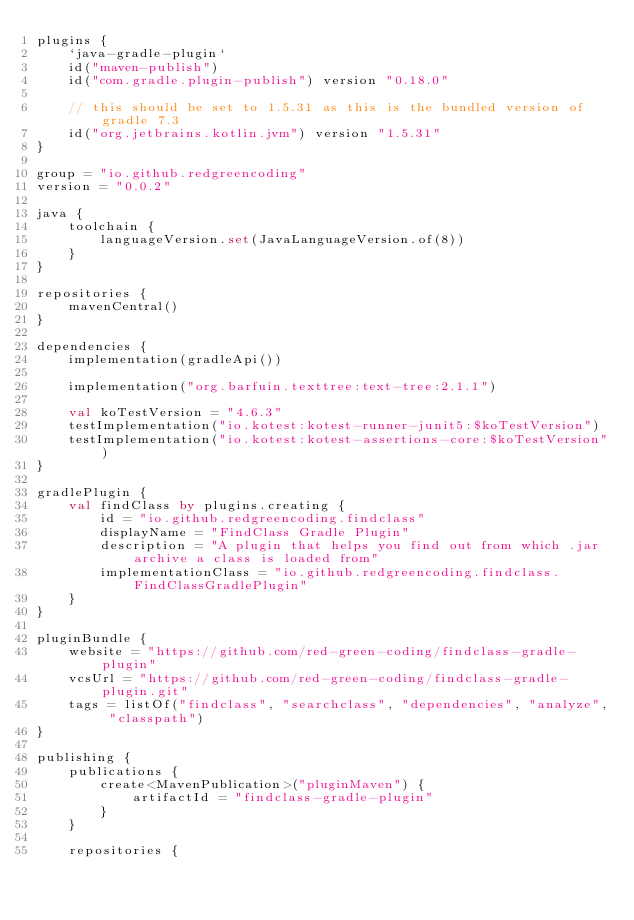<code> <loc_0><loc_0><loc_500><loc_500><_Kotlin_>plugins {
    `java-gradle-plugin`
    id("maven-publish")
    id("com.gradle.plugin-publish") version "0.18.0"

    // this should be set to 1.5.31 as this is the bundled version of gradle 7.3
    id("org.jetbrains.kotlin.jvm") version "1.5.31"
}

group = "io.github.redgreencoding"
version = "0.0.2"

java {
    toolchain {
        languageVersion.set(JavaLanguageVersion.of(8))
    }
}

repositories {
    mavenCentral()
}

dependencies {
    implementation(gradleApi())

    implementation("org.barfuin.texttree:text-tree:2.1.1")

    val koTestVersion = "4.6.3"
    testImplementation("io.kotest:kotest-runner-junit5:$koTestVersion")
    testImplementation("io.kotest:kotest-assertions-core:$koTestVersion")
}

gradlePlugin {
    val findClass by plugins.creating {
        id = "io.github.redgreencoding.findclass"
        displayName = "FindClass Gradle Plugin"
        description = "A plugin that helps you find out from which .jar archive a class is loaded from"
        implementationClass = "io.github.redgreencoding.findclass.FindClassGradlePlugin"
    }
}

pluginBundle {
    website = "https://github.com/red-green-coding/findclass-gradle-plugin"
    vcsUrl = "https://github.com/red-green-coding/findclass-gradle-plugin.git"
    tags = listOf("findclass", "searchclass", "dependencies", "analyze", "classpath")
}

publishing {
    publications {
        create<MavenPublication>("pluginMaven") {
            artifactId = "findclass-gradle-plugin"
        }
    }

    repositories {</code> 